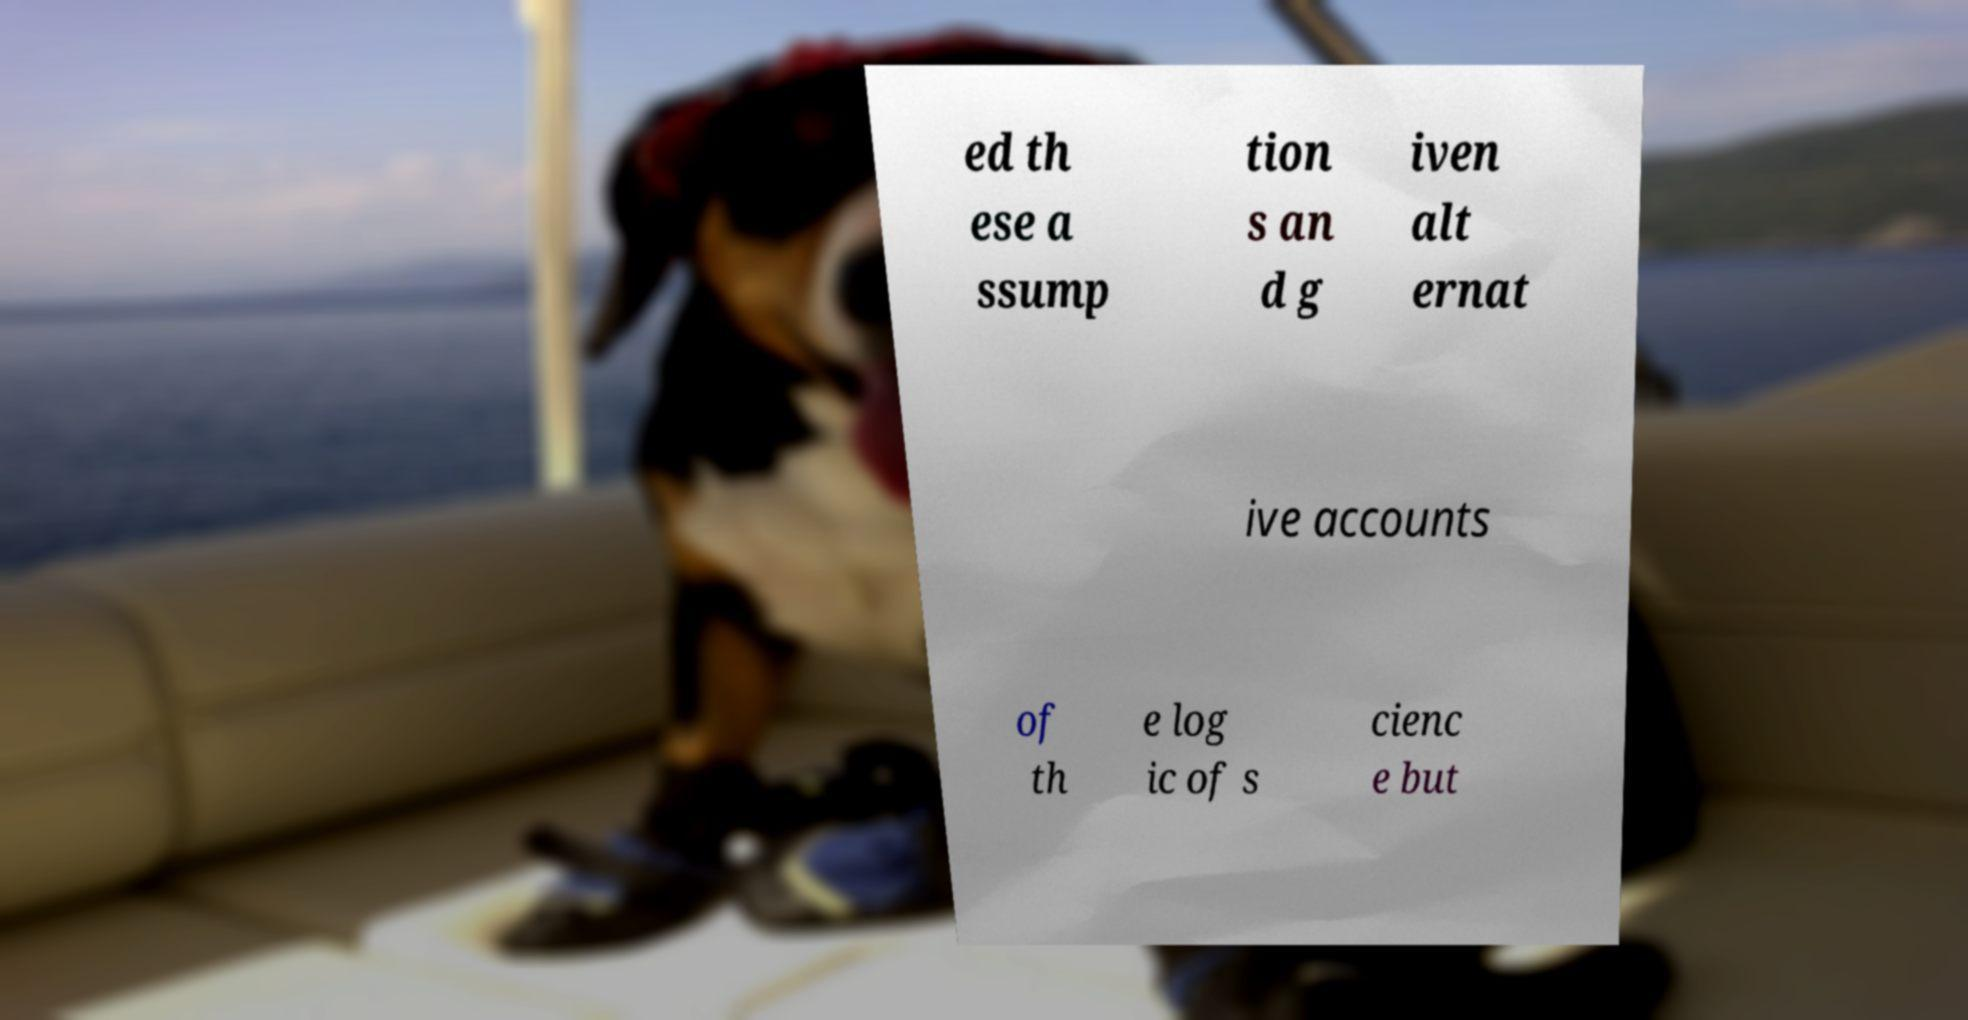Please identify and transcribe the text found in this image. ed th ese a ssump tion s an d g iven alt ernat ive accounts of th e log ic of s cienc e but 